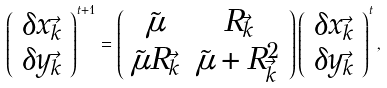Convert formula to latex. <formula><loc_0><loc_0><loc_500><loc_500>\left ( \begin{array} { c } \delta x _ { \vec { k } } \\ \delta y _ { \vec { k } } \end{array} \right ) ^ { t + 1 } = \left ( \begin{array} { c c } \tilde { \mu } & R _ { \vec { k } } \\ \tilde { \mu } R _ { \vec { k } } & \tilde { \mu } + R _ { \vec { k } } ^ { 2 } \end{array} \right ) \left ( \begin{array} { c } \delta x _ { \vec { k } } \\ \delta y _ { \vec { k } } \end{array} \right ) ^ { t } ,</formula> 